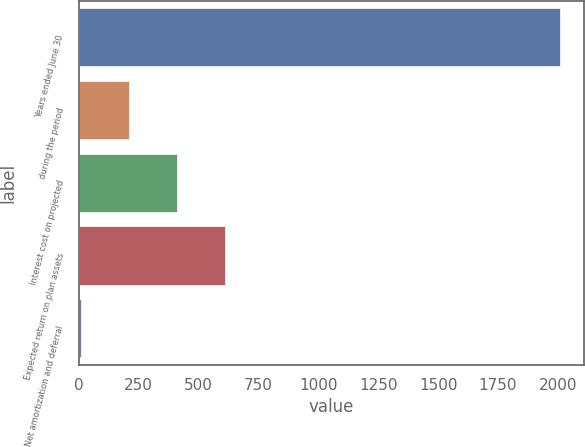Convert chart to OTSL. <chart><loc_0><loc_0><loc_500><loc_500><bar_chart><fcel>Years ended June 30<fcel>during the period<fcel>Interest cost on projected<fcel>Expected return on plan assets<fcel>Net amortization and deferral<nl><fcel>2008<fcel>210.16<fcel>409.92<fcel>609.68<fcel>10.4<nl></chart> 